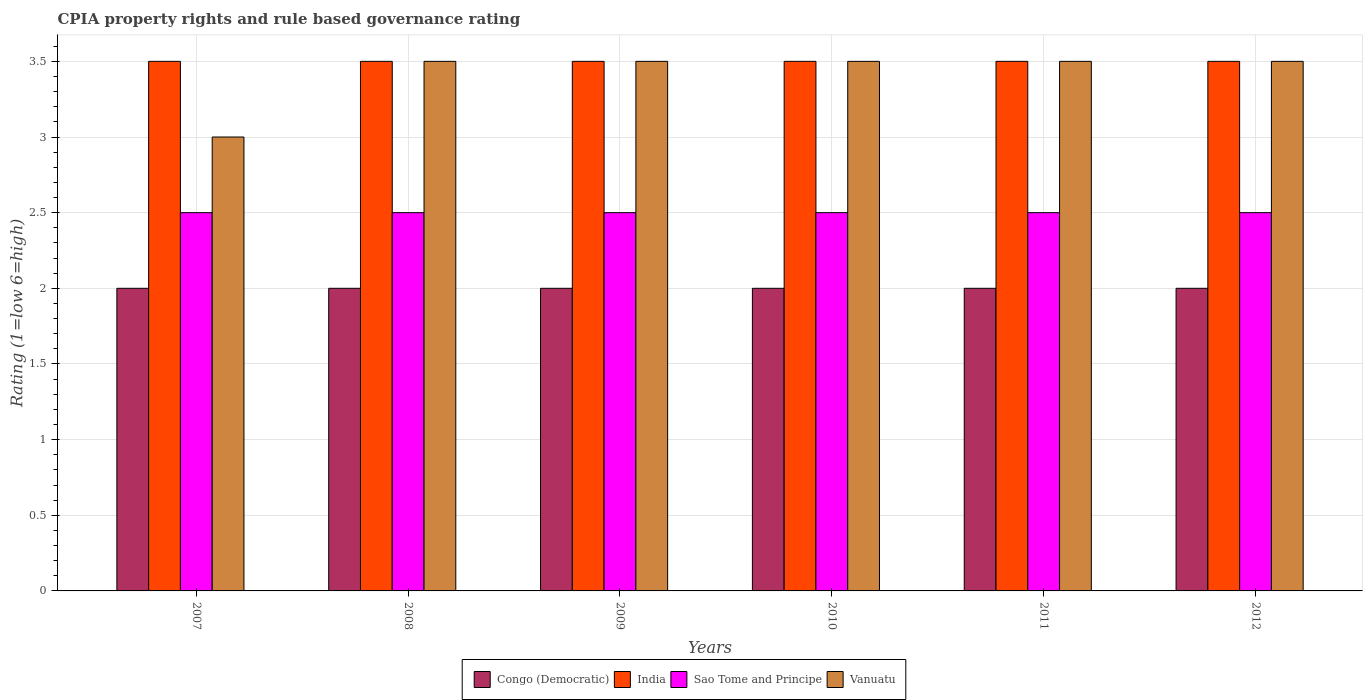How many different coloured bars are there?
Provide a succinct answer. 4. How many groups of bars are there?
Your answer should be compact. 6. Are the number of bars on each tick of the X-axis equal?
Make the answer very short. Yes. How many bars are there on the 6th tick from the right?
Your answer should be very brief. 4. In how many cases, is the number of bars for a given year not equal to the number of legend labels?
Give a very brief answer. 0. Across all years, what is the maximum CPIA rating in India?
Your response must be concise. 3.5. Across all years, what is the minimum CPIA rating in Vanuatu?
Provide a short and direct response. 3. What is the total CPIA rating in Vanuatu in the graph?
Keep it short and to the point. 20.5. What is the average CPIA rating in Vanuatu per year?
Keep it short and to the point. 3.42. In the year 2007, what is the difference between the CPIA rating in India and CPIA rating in Vanuatu?
Make the answer very short. 0.5. In how many years, is the CPIA rating in Congo (Democratic) greater than 0.4?
Provide a short and direct response. 6. What is the ratio of the CPIA rating in Sao Tome and Principe in 2009 to that in 2010?
Provide a succinct answer. 1. Is the CPIA rating in India in 2008 less than that in 2010?
Make the answer very short. No. In how many years, is the CPIA rating in India greater than the average CPIA rating in India taken over all years?
Give a very brief answer. 0. Is it the case that in every year, the sum of the CPIA rating in Congo (Democratic) and CPIA rating in India is greater than the sum of CPIA rating in Vanuatu and CPIA rating in Sao Tome and Principe?
Your answer should be very brief. No. What does the 3rd bar from the left in 2011 represents?
Provide a succinct answer. Sao Tome and Principe. What does the 2nd bar from the right in 2011 represents?
Provide a short and direct response. Sao Tome and Principe. Is it the case that in every year, the sum of the CPIA rating in India and CPIA rating in Congo (Democratic) is greater than the CPIA rating in Vanuatu?
Make the answer very short. Yes. How many years are there in the graph?
Make the answer very short. 6. Where does the legend appear in the graph?
Provide a succinct answer. Bottom center. How many legend labels are there?
Your answer should be compact. 4. What is the title of the graph?
Give a very brief answer. CPIA property rights and rule based governance rating. Does "South Africa" appear as one of the legend labels in the graph?
Your response must be concise. No. What is the label or title of the X-axis?
Offer a very short reply. Years. What is the Rating (1=low 6=high) of Vanuatu in 2007?
Ensure brevity in your answer.  3. What is the Rating (1=low 6=high) in Sao Tome and Principe in 2008?
Make the answer very short. 2.5. What is the Rating (1=low 6=high) in Vanuatu in 2008?
Give a very brief answer. 3.5. What is the Rating (1=low 6=high) of Sao Tome and Principe in 2009?
Offer a very short reply. 2.5. What is the Rating (1=low 6=high) in Vanuatu in 2010?
Make the answer very short. 3.5. What is the Rating (1=low 6=high) in Congo (Democratic) in 2011?
Offer a very short reply. 2. What is the Rating (1=low 6=high) of India in 2011?
Your answer should be very brief. 3.5. What is the Rating (1=low 6=high) of India in 2012?
Give a very brief answer. 3.5. What is the Rating (1=low 6=high) of Vanuatu in 2012?
Provide a short and direct response. 3.5. Across all years, what is the maximum Rating (1=low 6=high) of Congo (Democratic)?
Ensure brevity in your answer.  2. Across all years, what is the minimum Rating (1=low 6=high) of Congo (Democratic)?
Provide a short and direct response. 2. Across all years, what is the minimum Rating (1=low 6=high) in India?
Your response must be concise. 3.5. What is the total Rating (1=low 6=high) in Congo (Democratic) in the graph?
Make the answer very short. 12. What is the difference between the Rating (1=low 6=high) of India in 2007 and that in 2008?
Provide a succinct answer. 0. What is the difference between the Rating (1=low 6=high) in Sao Tome and Principe in 2007 and that in 2008?
Provide a succinct answer. 0. What is the difference between the Rating (1=low 6=high) in Vanuatu in 2007 and that in 2008?
Provide a succinct answer. -0.5. What is the difference between the Rating (1=low 6=high) of Sao Tome and Principe in 2007 and that in 2009?
Your answer should be compact. 0. What is the difference between the Rating (1=low 6=high) of Vanuatu in 2007 and that in 2009?
Ensure brevity in your answer.  -0.5. What is the difference between the Rating (1=low 6=high) in Vanuatu in 2007 and that in 2010?
Ensure brevity in your answer.  -0.5. What is the difference between the Rating (1=low 6=high) of Vanuatu in 2007 and that in 2011?
Offer a terse response. -0.5. What is the difference between the Rating (1=low 6=high) in Congo (Democratic) in 2007 and that in 2012?
Your response must be concise. 0. What is the difference between the Rating (1=low 6=high) of Sao Tome and Principe in 2007 and that in 2012?
Ensure brevity in your answer.  0. What is the difference between the Rating (1=low 6=high) in India in 2008 and that in 2009?
Ensure brevity in your answer.  0. What is the difference between the Rating (1=low 6=high) in Vanuatu in 2008 and that in 2009?
Provide a succinct answer. 0. What is the difference between the Rating (1=low 6=high) in India in 2008 and that in 2010?
Your answer should be compact. 0. What is the difference between the Rating (1=low 6=high) in Vanuatu in 2008 and that in 2010?
Keep it short and to the point. 0. What is the difference between the Rating (1=low 6=high) of Congo (Democratic) in 2008 and that in 2011?
Ensure brevity in your answer.  0. What is the difference between the Rating (1=low 6=high) of Sao Tome and Principe in 2008 and that in 2011?
Provide a succinct answer. 0. What is the difference between the Rating (1=low 6=high) of Sao Tome and Principe in 2008 and that in 2012?
Offer a terse response. 0. What is the difference between the Rating (1=low 6=high) in Sao Tome and Principe in 2009 and that in 2010?
Make the answer very short. 0. What is the difference between the Rating (1=low 6=high) of India in 2009 and that in 2012?
Your answer should be compact. 0. What is the difference between the Rating (1=low 6=high) of Sao Tome and Principe in 2009 and that in 2012?
Provide a succinct answer. 0. What is the difference between the Rating (1=low 6=high) of Vanuatu in 2009 and that in 2012?
Provide a short and direct response. 0. What is the difference between the Rating (1=low 6=high) of Congo (Democratic) in 2010 and that in 2011?
Ensure brevity in your answer.  0. What is the difference between the Rating (1=low 6=high) in India in 2010 and that in 2011?
Your answer should be very brief. 0. What is the difference between the Rating (1=low 6=high) in Sao Tome and Principe in 2010 and that in 2011?
Your answer should be very brief. 0. What is the difference between the Rating (1=low 6=high) of Vanuatu in 2010 and that in 2011?
Provide a short and direct response. 0. What is the difference between the Rating (1=low 6=high) of Congo (Democratic) in 2010 and that in 2012?
Offer a very short reply. 0. What is the difference between the Rating (1=low 6=high) in Sao Tome and Principe in 2010 and that in 2012?
Give a very brief answer. 0. What is the difference between the Rating (1=low 6=high) of India in 2011 and that in 2012?
Your answer should be very brief. 0. What is the difference between the Rating (1=low 6=high) in Congo (Democratic) in 2007 and the Rating (1=low 6=high) in Vanuatu in 2008?
Provide a short and direct response. -1.5. What is the difference between the Rating (1=low 6=high) in India in 2007 and the Rating (1=low 6=high) in Sao Tome and Principe in 2008?
Make the answer very short. 1. What is the difference between the Rating (1=low 6=high) in India in 2007 and the Rating (1=low 6=high) in Sao Tome and Principe in 2009?
Ensure brevity in your answer.  1. What is the difference between the Rating (1=low 6=high) in Sao Tome and Principe in 2007 and the Rating (1=low 6=high) in Vanuatu in 2009?
Offer a terse response. -1. What is the difference between the Rating (1=low 6=high) of India in 2007 and the Rating (1=low 6=high) of Sao Tome and Principe in 2010?
Your answer should be very brief. 1. What is the difference between the Rating (1=low 6=high) of India in 2007 and the Rating (1=low 6=high) of Vanuatu in 2010?
Offer a terse response. 0. What is the difference between the Rating (1=low 6=high) of Sao Tome and Principe in 2007 and the Rating (1=low 6=high) of Vanuatu in 2010?
Offer a very short reply. -1. What is the difference between the Rating (1=low 6=high) in India in 2007 and the Rating (1=low 6=high) in Sao Tome and Principe in 2011?
Make the answer very short. 1. What is the difference between the Rating (1=low 6=high) of India in 2007 and the Rating (1=low 6=high) of Vanuatu in 2011?
Ensure brevity in your answer.  0. What is the difference between the Rating (1=low 6=high) in Sao Tome and Principe in 2007 and the Rating (1=low 6=high) in Vanuatu in 2011?
Make the answer very short. -1. What is the difference between the Rating (1=low 6=high) of Congo (Democratic) in 2007 and the Rating (1=low 6=high) of India in 2012?
Your answer should be very brief. -1.5. What is the difference between the Rating (1=low 6=high) of Congo (Democratic) in 2007 and the Rating (1=low 6=high) of Sao Tome and Principe in 2012?
Provide a succinct answer. -0.5. What is the difference between the Rating (1=low 6=high) of India in 2007 and the Rating (1=low 6=high) of Sao Tome and Principe in 2012?
Your response must be concise. 1. What is the difference between the Rating (1=low 6=high) of Congo (Democratic) in 2008 and the Rating (1=low 6=high) of India in 2009?
Offer a very short reply. -1.5. What is the difference between the Rating (1=low 6=high) in Congo (Democratic) in 2008 and the Rating (1=low 6=high) in Sao Tome and Principe in 2009?
Keep it short and to the point. -0.5. What is the difference between the Rating (1=low 6=high) of Congo (Democratic) in 2008 and the Rating (1=low 6=high) of Vanuatu in 2009?
Ensure brevity in your answer.  -1.5. What is the difference between the Rating (1=low 6=high) in India in 2008 and the Rating (1=low 6=high) in Sao Tome and Principe in 2009?
Your response must be concise. 1. What is the difference between the Rating (1=low 6=high) of India in 2008 and the Rating (1=low 6=high) of Vanuatu in 2009?
Your response must be concise. 0. What is the difference between the Rating (1=low 6=high) of Congo (Democratic) in 2008 and the Rating (1=low 6=high) of India in 2010?
Your answer should be compact. -1.5. What is the difference between the Rating (1=low 6=high) of Congo (Democratic) in 2008 and the Rating (1=low 6=high) of Sao Tome and Principe in 2010?
Your response must be concise. -0.5. What is the difference between the Rating (1=low 6=high) in Congo (Democratic) in 2008 and the Rating (1=low 6=high) in Vanuatu in 2010?
Your response must be concise. -1.5. What is the difference between the Rating (1=low 6=high) of India in 2008 and the Rating (1=low 6=high) of Sao Tome and Principe in 2010?
Make the answer very short. 1. What is the difference between the Rating (1=low 6=high) of India in 2008 and the Rating (1=low 6=high) of Vanuatu in 2010?
Offer a terse response. 0. What is the difference between the Rating (1=low 6=high) in Congo (Democratic) in 2008 and the Rating (1=low 6=high) in India in 2011?
Offer a very short reply. -1.5. What is the difference between the Rating (1=low 6=high) in India in 2008 and the Rating (1=low 6=high) in Sao Tome and Principe in 2011?
Ensure brevity in your answer.  1. What is the difference between the Rating (1=low 6=high) in India in 2008 and the Rating (1=low 6=high) in Vanuatu in 2011?
Your answer should be compact. 0. What is the difference between the Rating (1=low 6=high) in Congo (Democratic) in 2008 and the Rating (1=low 6=high) in India in 2012?
Keep it short and to the point. -1.5. What is the difference between the Rating (1=low 6=high) in Congo (Democratic) in 2008 and the Rating (1=low 6=high) in Sao Tome and Principe in 2012?
Offer a terse response. -0.5. What is the difference between the Rating (1=low 6=high) in Congo (Democratic) in 2008 and the Rating (1=low 6=high) in Vanuatu in 2012?
Offer a terse response. -1.5. What is the difference between the Rating (1=low 6=high) of India in 2008 and the Rating (1=low 6=high) of Vanuatu in 2012?
Offer a very short reply. 0. What is the difference between the Rating (1=low 6=high) in Sao Tome and Principe in 2008 and the Rating (1=low 6=high) in Vanuatu in 2012?
Your answer should be very brief. -1. What is the difference between the Rating (1=low 6=high) of Congo (Democratic) in 2009 and the Rating (1=low 6=high) of Vanuatu in 2010?
Your answer should be compact. -1.5. What is the difference between the Rating (1=low 6=high) of Sao Tome and Principe in 2009 and the Rating (1=low 6=high) of Vanuatu in 2010?
Offer a very short reply. -1. What is the difference between the Rating (1=low 6=high) in Congo (Democratic) in 2009 and the Rating (1=low 6=high) in Sao Tome and Principe in 2011?
Provide a short and direct response. -0.5. What is the difference between the Rating (1=low 6=high) of Congo (Democratic) in 2009 and the Rating (1=low 6=high) of Vanuatu in 2011?
Provide a short and direct response. -1.5. What is the difference between the Rating (1=low 6=high) of Congo (Democratic) in 2009 and the Rating (1=low 6=high) of India in 2012?
Keep it short and to the point. -1.5. What is the difference between the Rating (1=low 6=high) of Congo (Democratic) in 2009 and the Rating (1=low 6=high) of Sao Tome and Principe in 2012?
Offer a very short reply. -0.5. What is the difference between the Rating (1=low 6=high) of India in 2009 and the Rating (1=low 6=high) of Sao Tome and Principe in 2012?
Keep it short and to the point. 1. What is the difference between the Rating (1=low 6=high) of India in 2009 and the Rating (1=low 6=high) of Vanuatu in 2012?
Offer a very short reply. 0. What is the difference between the Rating (1=low 6=high) in Congo (Democratic) in 2010 and the Rating (1=low 6=high) in Sao Tome and Principe in 2011?
Make the answer very short. -0.5. What is the difference between the Rating (1=low 6=high) in Congo (Democratic) in 2010 and the Rating (1=low 6=high) in Vanuatu in 2011?
Ensure brevity in your answer.  -1.5. What is the difference between the Rating (1=low 6=high) in Congo (Democratic) in 2010 and the Rating (1=low 6=high) in Sao Tome and Principe in 2012?
Give a very brief answer. -0.5. What is the difference between the Rating (1=low 6=high) in India in 2010 and the Rating (1=low 6=high) in Vanuatu in 2012?
Offer a terse response. 0. What is the difference between the Rating (1=low 6=high) in Congo (Democratic) in 2011 and the Rating (1=low 6=high) in Vanuatu in 2012?
Ensure brevity in your answer.  -1.5. What is the difference between the Rating (1=low 6=high) of India in 2011 and the Rating (1=low 6=high) of Sao Tome and Principe in 2012?
Your response must be concise. 1. What is the difference between the Rating (1=low 6=high) of India in 2011 and the Rating (1=low 6=high) of Vanuatu in 2012?
Make the answer very short. 0. What is the difference between the Rating (1=low 6=high) of Sao Tome and Principe in 2011 and the Rating (1=low 6=high) of Vanuatu in 2012?
Make the answer very short. -1. What is the average Rating (1=low 6=high) in Congo (Democratic) per year?
Offer a very short reply. 2. What is the average Rating (1=low 6=high) of India per year?
Your response must be concise. 3.5. What is the average Rating (1=low 6=high) in Sao Tome and Principe per year?
Your response must be concise. 2.5. What is the average Rating (1=low 6=high) in Vanuatu per year?
Offer a terse response. 3.42. In the year 2007, what is the difference between the Rating (1=low 6=high) of Congo (Democratic) and Rating (1=low 6=high) of India?
Provide a short and direct response. -1.5. In the year 2007, what is the difference between the Rating (1=low 6=high) in Congo (Democratic) and Rating (1=low 6=high) in Sao Tome and Principe?
Your answer should be very brief. -0.5. In the year 2007, what is the difference between the Rating (1=low 6=high) in Congo (Democratic) and Rating (1=low 6=high) in Vanuatu?
Provide a short and direct response. -1. In the year 2007, what is the difference between the Rating (1=low 6=high) in India and Rating (1=low 6=high) in Sao Tome and Principe?
Ensure brevity in your answer.  1. In the year 2007, what is the difference between the Rating (1=low 6=high) in India and Rating (1=low 6=high) in Vanuatu?
Your response must be concise. 0.5. In the year 2007, what is the difference between the Rating (1=low 6=high) of Sao Tome and Principe and Rating (1=low 6=high) of Vanuatu?
Keep it short and to the point. -0.5. In the year 2008, what is the difference between the Rating (1=low 6=high) of Congo (Democratic) and Rating (1=low 6=high) of Vanuatu?
Your response must be concise. -1.5. In the year 2008, what is the difference between the Rating (1=low 6=high) of Sao Tome and Principe and Rating (1=low 6=high) of Vanuatu?
Your answer should be compact. -1. In the year 2009, what is the difference between the Rating (1=low 6=high) of Congo (Democratic) and Rating (1=low 6=high) of India?
Your answer should be very brief. -1.5. In the year 2010, what is the difference between the Rating (1=low 6=high) in Congo (Democratic) and Rating (1=low 6=high) in India?
Your response must be concise. -1.5. In the year 2010, what is the difference between the Rating (1=low 6=high) in Congo (Democratic) and Rating (1=low 6=high) in Sao Tome and Principe?
Make the answer very short. -0.5. In the year 2010, what is the difference between the Rating (1=low 6=high) of India and Rating (1=low 6=high) of Sao Tome and Principe?
Give a very brief answer. 1. In the year 2010, what is the difference between the Rating (1=low 6=high) of India and Rating (1=low 6=high) of Vanuatu?
Give a very brief answer. 0. In the year 2011, what is the difference between the Rating (1=low 6=high) in Congo (Democratic) and Rating (1=low 6=high) in Sao Tome and Principe?
Give a very brief answer. -0.5. In the year 2011, what is the difference between the Rating (1=low 6=high) of India and Rating (1=low 6=high) of Vanuatu?
Provide a succinct answer. 0. In the year 2011, what is the difference between the Rating (1=low 6=high) of Sao Tome and Principe and Rating (1=low 6=high) of Vanuatu?
Ensure brevity in your answer.  -1. In the year 2012, what is the difference between the Rating (1=low 6=high) of Congo (Democratic) and Rating (1=low 6=high) of India?
Offer a terse response. -1.5. In the year 2012, what is the difference between the Rating (1=low 6=high) of Congo (Democratic) and Rating (1=low 6=high) of Sao Tome and Principe?
Provide a succinct answer. -0.5. In the year 2012, what is the difference between the Rating (1=low 6=high) of India and Rating (1=low 6=high) of Sao Tome and Principe?
Your answer should be very brief. 1. In the year 2012, what is the difference between the Rating (1=low 6=high) of India and Rating (1=low 6=high) of Vanuatu?
Offer a terse response. 0. In the year 2012, what is the difference between the Rating (1=low 6=high) of Sao Tome and Principe and Rating (1=low 6=high) of Vanuatu?
Provide a succinct answer. -1. What is the ratio of the Rating (1=low 6=high) of Congo (Democratic) in 2007 to that in 2008?
Offer a very short reply. 1. What is the ratio of the Rating (1=low 6=high) in India in 2007 to that in 2008?
Ensure brevity in your answer.  1. What is the ratio of the Rating (1=low 6=high) in Sao Tome and Principe in 2007 to that in 2008?
Ensure brevity in your answer.  1. What is the ratio of the Rating (1=low 6=high) of Vanuatu in 2007 to that in 2008?
Ensure brevity in your answer.  0.86. What is the ratio of the Rating (1=low 6=high) in Sao Tome and Principe in 2007 to that in 2009?
Offer a very short reply. 1. What is the ratio of the Rating (1=low 6=high) in Vanuatu in 2007 to that in 2009?
Offer a very short reply. 0.86. What is the ratio of the Rating (1=low 6=high) of Congo (Democratic) in 2007 to that in 2010?
Offer a very short reply. 1. What is the ratio of the Rating (1=low 6=high) of India in 2007 to that in 2010?
Provide a succinct answer. 1. What is the ratio of the Rating (1=low 6=high) in Congo (Democratic) in 2007 to that in 2011?
Your response must be concise. 1. What is the ratio of the Rating (1=low 6=high) of India in 2007 to that in 2011?
Your answer should be compact. 1. What is the ratio of the Rating (1=low 6=high) in Sao Tome and Principe in 2007 to that in 2011?
Your answer should be compact. 1. What is the ratio of the Rating (1=low 6=high) of India in 2007 to that in 2012?
Provide a short and direct response. 1. What is the ratio of the Rating (1=low 6=high) of Vanuatu in 2007 to that in 2012?
Keep it short and to the point. 0.86. What is the ratio of the Rating (1=low 6=high) in Congo (Democratic) in 2008 to that in 2009?
Your answer should be very brief. 1. What is the ratio of the Rating (1=low 6=high) of India in 2008 to that in 2009?
Give a very brief answer. 1. What is the ratio of the Rating (1=low 6=high) of Sao Tome and Principe in 2008 to that in 2009?
Provide a short and direct response. 1. What is the ratio of the Rating (1=low 6=high) in India in 2008 to that in 2010?
Provide a short and direct response. 1. What is the ratio of the Rating (1=low 6=high) of India in 2008 to that in 2011?
Ensure brevity in your answer.  1. What is the ratio of the Rating (1=low 6=high) in Sao Tome and Principe in 2008 to that in 2011?
Make the answer very short. 1. What is the ratio of the Rating (1=low 6=high) in Congo (Democratic) in 2008 to that in 2012?
Make the answer very short. 1. What is the ratio of the Rating (1=low 6=high) in Sao Tome and Principe in 2008 to that in 2012?
Provide a succinct answer. 1. What is the ratio of the Rating (1=low 6=high) in Vanuatu in 2008 to that in 2012?
Ensure brevity in your answer.  1. What is the ratio of the Rating (1=low 6=high) in Vanuatu in 2009 to that in 2010?
Your answer should be very brief. 1. What is the ratio of the Rating (1=low 6=high) of Sao Tome and Principe in 2009 to that in 2011?
Your answer should be compact. 1. What is the ratio of the Rating (1=low 6=high) in Vanuatu in 2009 to that in 2011?
Make the answer very short. 1. What is the ratio of the Rating (1=low 6=high) in Congo (Democratic) in 2009 to that in 2012?
Provide a succinct answer. 1. What is the ratio of the Rating (1=low 6=high) in India in 2009 to that in 2012?
Keep it short and to the point. 1. What is the ratio of the Rating (1=low 6=high) of Vanuatu in 2009 to that in 2012?
Offer a very short reply. 1. What is the ratio of the Rating (1=low 6=high) in Congo (Democratic) in 2010 to that in 2011?
Your response must be concise. 1. What is the ratio of the Rating (1=low 6=high) in Sao Tome and Principe in 2010 to that in 2011?
Your answer should be very brief. 1. What is the ratio of the Rating (1=low 6=high) in Congo (Democratic) in 2011 to that in 2012?
Ensure brevity in your answer.  1. What is the ratio of the Rating (1=low 6=high) of Sao Tome and Principe in 2011 to that in 2012?
Provide a short and direct response. 1. What is the difference between the highest and the second highest Rating (1=low 6=high) in India?
Offer a terse response. 0. What is the difference between the highest and the second highest Rating (1=low 6=high) of Sao Tome and Principe?
Make the answer very short. 0. What is the difference between the highest and the second highest Rating (1=low 6=high) in Vanuatu?
Your answer should be very brief. 0. What is the difference between the highest and the lowest Rating (1=low 6=high) in Congo (Democratic)?
Ensure brevity in your answer.  0. What is the difference between the highest and the lowest Rating (1=low 6=high) in Sao Tome and Principe?
Your answer should be compact. 0. 